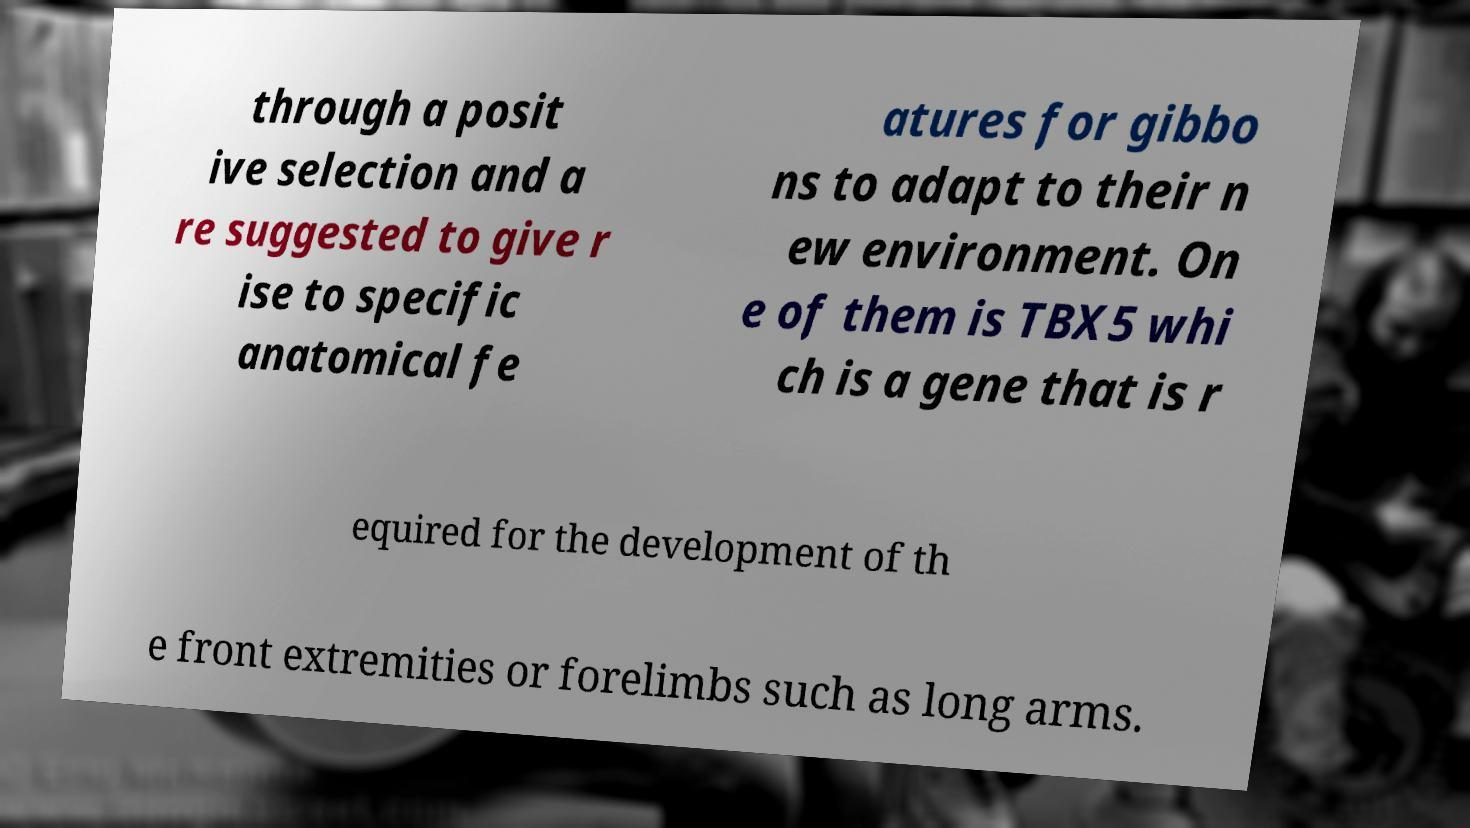I need the written content from this picture converted into text. Can you do that? through a posit ive selection and a re suggested to give r ise to specific anatomical fe atures for gibbo ns to adapt to their n ew environment. On e of them is TBX5 whi ch is a gene that is r equired for the development of th e front extremities or forelimbs such as long arms. 